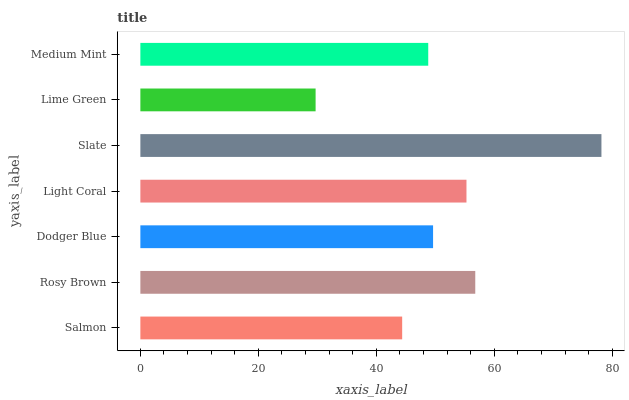Is Lime Green the minimum?
Answer yes or no. Yes. Is Slate the maximum?
Answer yes or no. Yes. Is Rosy Brown the minimum?
Answer yes or no. No. Is Rosy Brown the maximum?
Answer yes or no. No. Is Rosy Brown greater than Salmon?
Answer yes or no. Yes. Is Salmon less than Rosy Brown?
Answer yes or no. Yes. Is Salmon greater than Rosy Brown?
Answer yes or no. No. Is Rosy Brown less than Salmon?
Answer yes or no. No. Is Dodger Blue the high median?
Answer yes or no. Yes. Is Dodger Blue the low median?
Answer yes or no. Yes. Is Slate the high median?
Answer yes or no. No. Is Slate the low median?
Answer yes or no. No. 